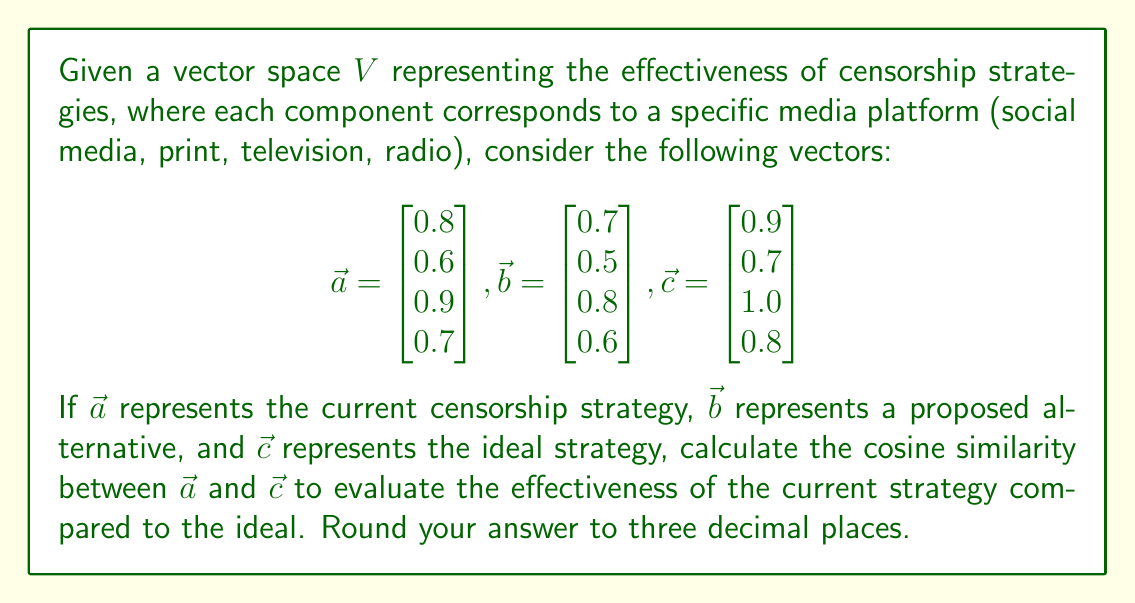Help me with this question. To calculate the cosine similarity between vectors $\vec{a}$ and $\vec{c}$, we use the formula:

$$\cos \theta = \frac{\vec{a} \cdot \vec{c}}{|\vec{a}| |\vec{c}|}$$

Step 1: Calculate the dot product $\vec{a} \cdot \vec{c}$
$$\vec{a} \cdot \vec{c} = (0.8)(0.9) + (0.6)(0.7) + (0.9)(1.0) + (0.7)(0.8) = 2.59$$

Step 2: Calculate the magnitudes $|\vec{a}|$ and $|\vec{c}|$
$$|\vec{a}| = \sqrt{0.8^2 + 0.6^2 + 0.9^2 + 0.7^2} = \sqrt{2.30} = 1.517$$
$$|\vec{c}| = \sqrt{0.9^2 + 0.7^2 + 1.0^2 + 0.8^2} = \sqrt{2.74} = 1.655$$

Step 3: Apply the cosine similarity formula
$$\cos \theta = \frac{2.59}{(1.517)(1.655)} = 0.9987$$

Step 4: Round to three decimal places
$$\cos \theta \approx 0.999$$

This high cosine similarity (very close to 1) indicates that the current censorship strategy is highly effective and closely aligned with the ideal strategy across all media platforms.
Answer: 0.999 